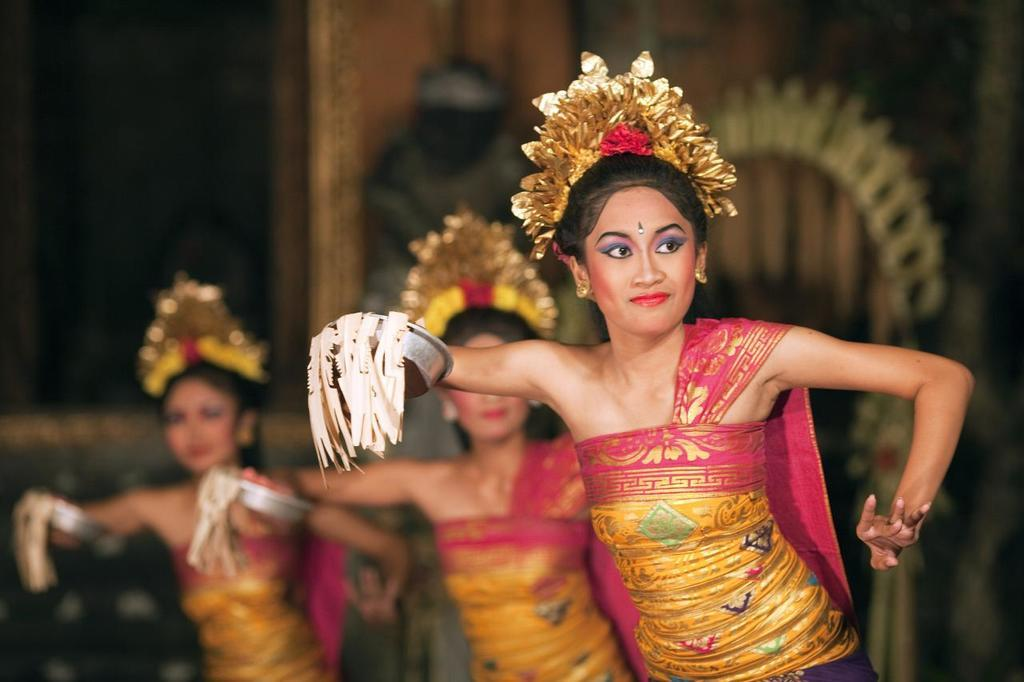Who is present in the image? There are women in the image. What are the women wearing on their heads? The women are wearing crowns. What objects are the women holding in their hands? The women are holding bowls in their hands. What type of ball is being used by the women in the image? There is no ball present in the image; the women are holding bowls in their hands. 